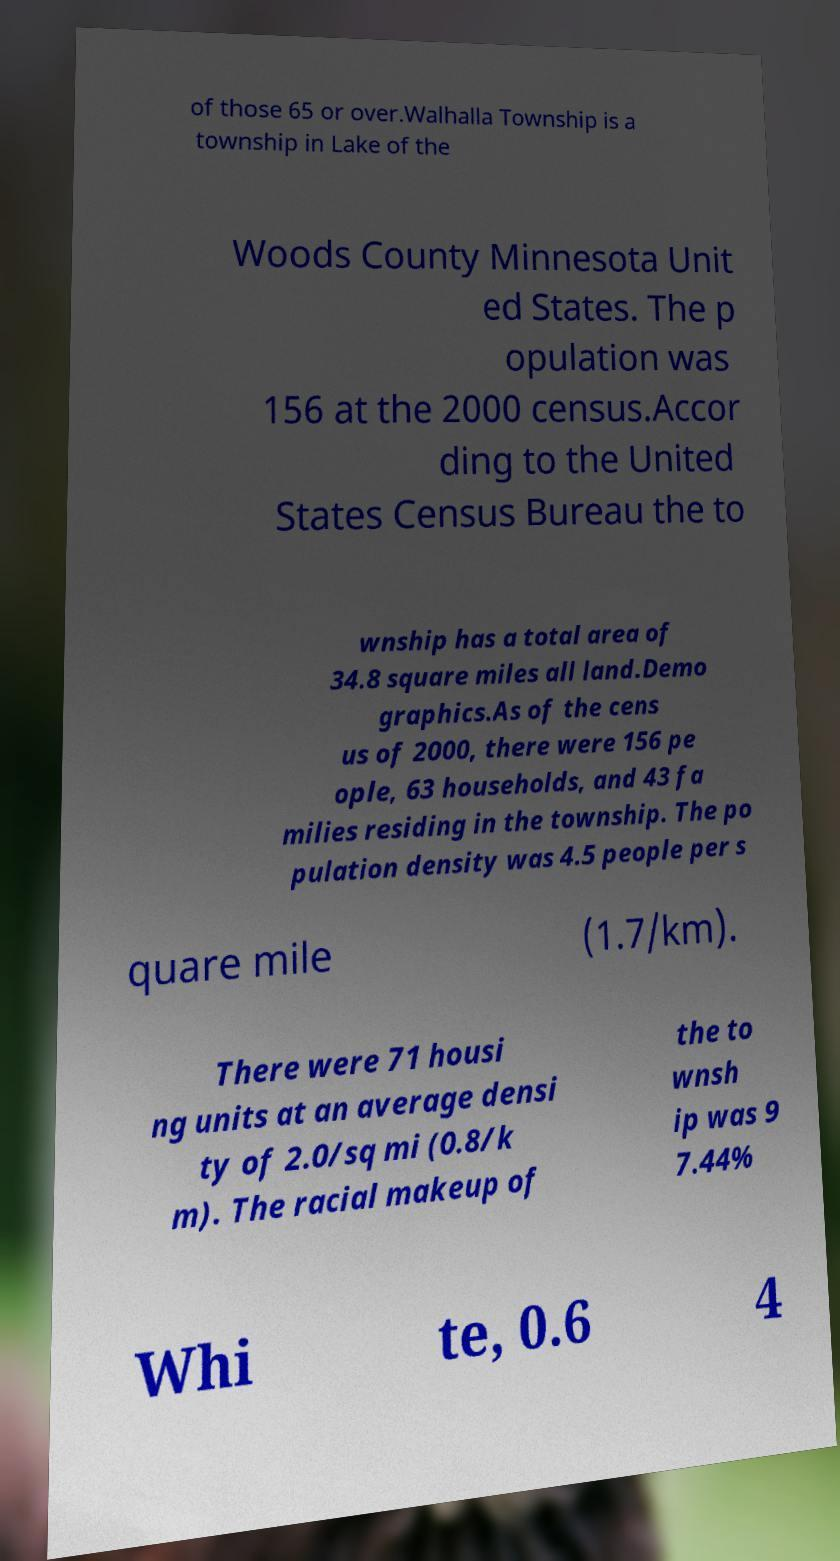Can you read and provide the text displayed in the image?This photo seems to have some interesting text. Can you extract and type it out for me? of those 65 or over.Walhalla Township is a township in Lake of the Woods County Minnesota Unit ed States. The p opulation was 156 at the 2000 census.Accor ding to the United States Census Bureau the to wnship has a total area of 34.8 square miles all land.Demo graphics.As of the cens us of 2000, there were 156 pe ople, 63 households, and 43 fa milies residing in the township. The po pulation density was 4.5 people per s quare mile (1.7/km). There were 71 housi ng units at an average densi ty of 2.0/sq mi (0.8/k m). The racial makeup of the to wnsh ip was 9 7.44% Whi te, 0.6 4 